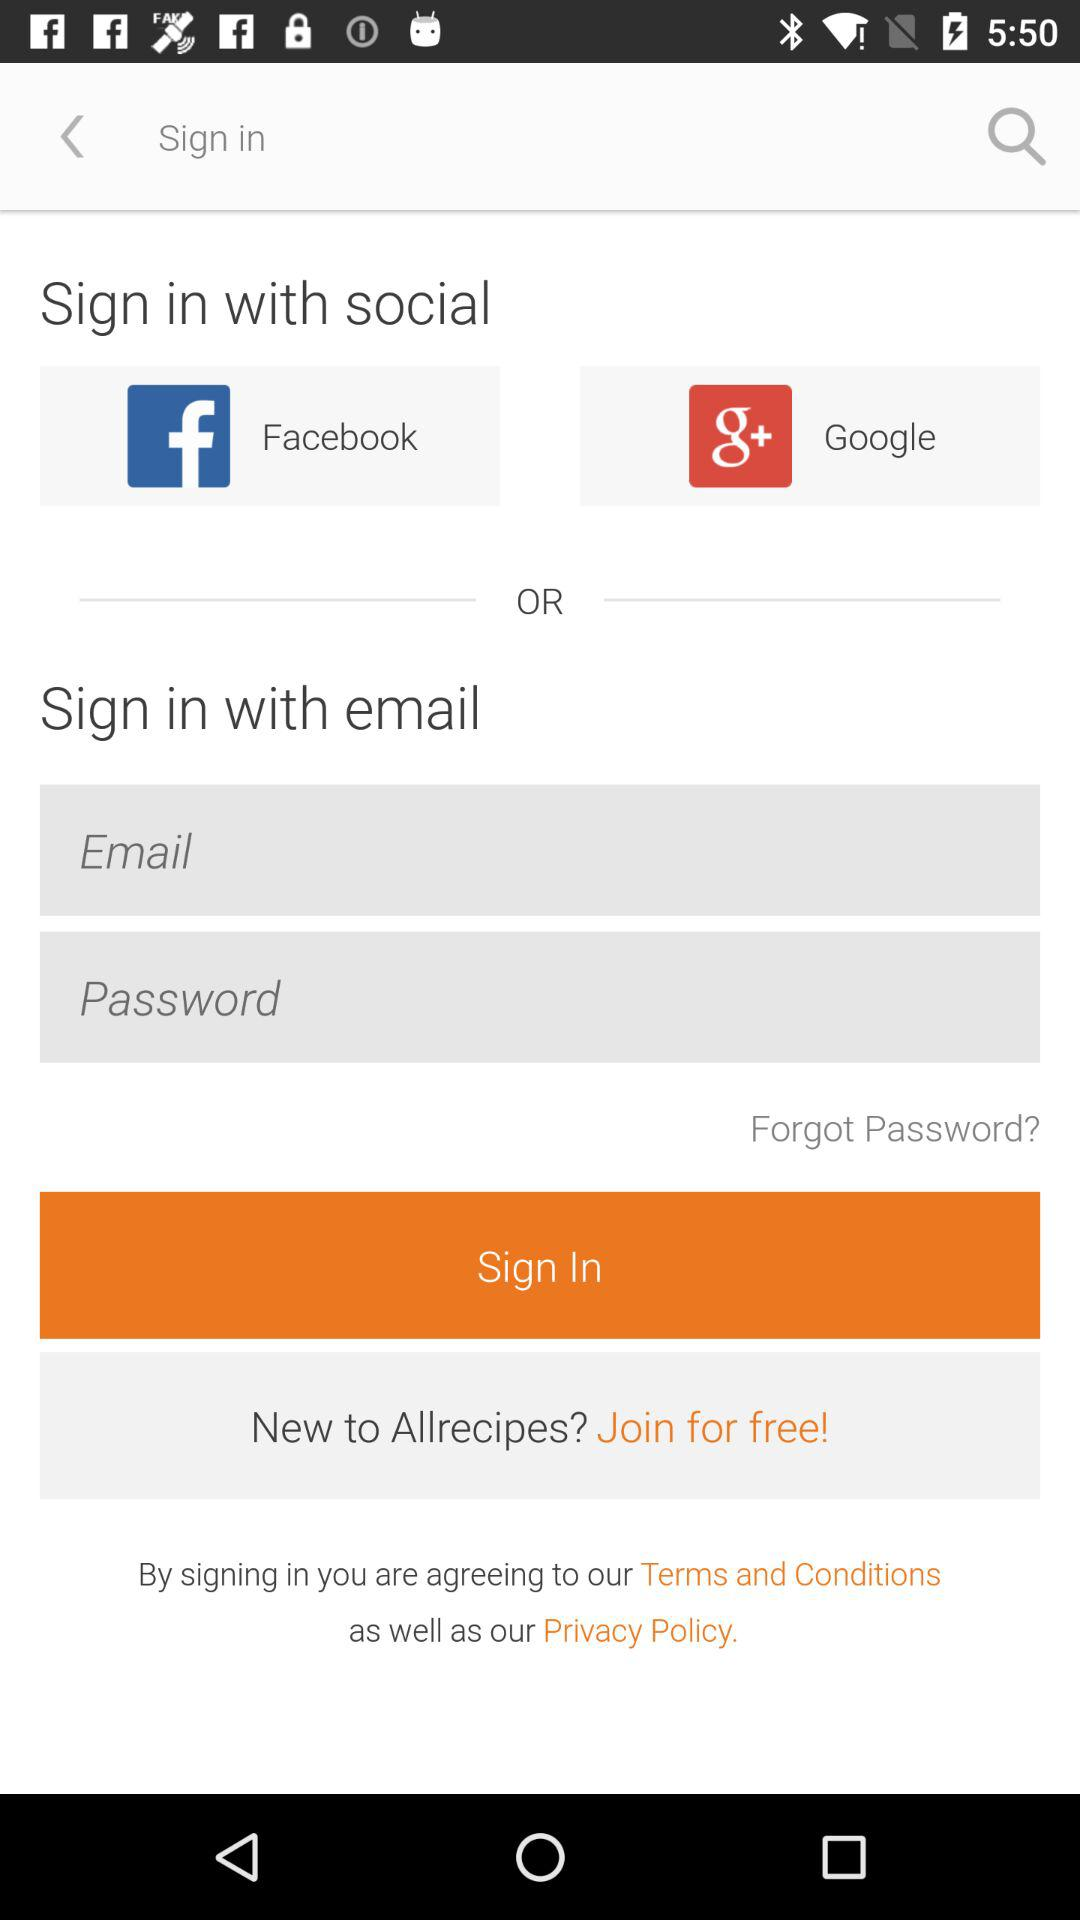What is the name of the application? The name of the application is "Allrecipes". 